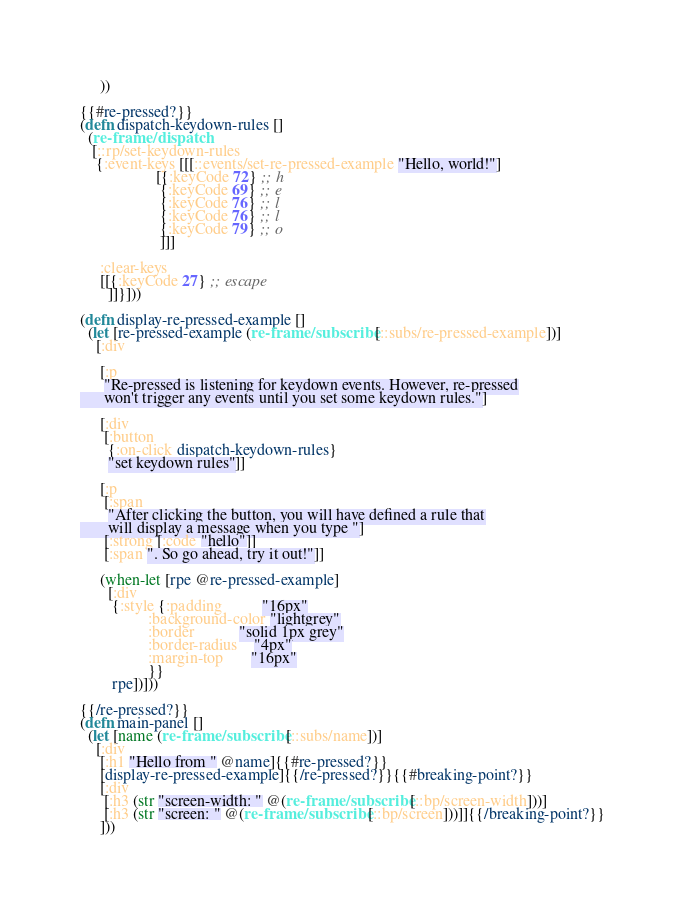<code> <loc_0><loc_0><loc_500><loc_500><_Clojure_>     ))

{{#re-pressed?}}
(defn dispatch-keydown-rules []
  (re-frame/dispatch
   [::rp/set-keydown-rules
    {:event-keys [[[::events/set-re-pressed-example "Hello, world!"]
                   [{:keyCode 72} ;; h
                    {:keyCode 69} ;; e
                    {:keyCode 76} ;; l
                    {:keyCode 76} ;; l
                    {:keyCode 79} ;; o
                    ]]]

     :clear-keys
     [[{:keyCode 27} ;; escape
       ]]}]))

(defn display-re-pressed-example []
  (let [re-pressed-example (re-frame/subscribe [::subs/re-pressed-example])]
    [:div

     [:p
      "Re-pressed is listening for keydown events. However, re-pressed
      won't trigger any events until you set some keydown rules."]

     [:div
      [:button
       {:on-click dispatch-keydown-rules}
       "set keydown rules"]]

     [:p
      [:span
       "After clicking the button, you will have defined a rule that
       will display a message when you type "]
      [:strong [:code "hello"]]
      [:span ". So go ahead, try it out!"]]

     (when-let [rpe @re-pressed-example]
       [:div
        {:style {:padding          "16px"
                 :background-color "lightgrey"
                 :border           "solid 1px grey"
                 :border-radius    "4px"
                 :margin-top       "16px"
                 }}
        rpe])]))

{{/re-pressed?}}
(defn main-panel []
  (let [name (re-frame/subscribe [::subs/name])]
    [:div
     [:h1 "Hello from " @name]{{#re-pressed?}}
     [display-re-pressed-example]{{/re-pressed?}}{{#breaking-point?}}
     [:div
      [:h3 (str "screen-width: " @(re-frame/subscribe [::bp/screen-width]))]
      [:h3 (str "screen: " @(re-frame/subscribe [::bp/screen]))]]{{/breaking-point?}}
     ]))
</code> 